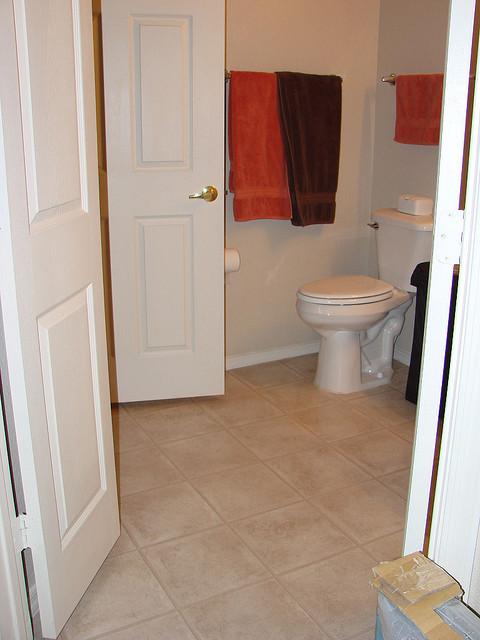How many towels are in the bathroom?
Answer briefly. 3. What shape is the tile on the floor?
Write a very short answer. Square. What is the white object behind the door?
Keep it brief. Toilet paper. 